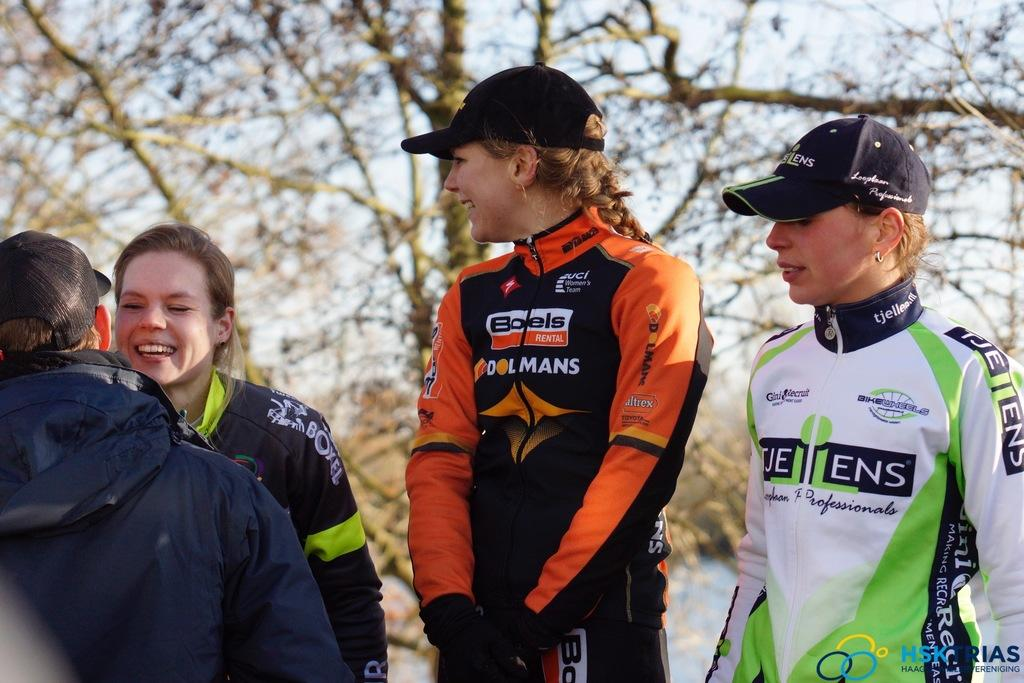What is happening in the image? There is a group of people in the image, and they are standing. How are the people in the image feeling? The people in the image are smiling. Can you describe any accessories the people are wearing? Some of the people are wearing caps. What can be seen in the background of the image? There are trees and the sky visible in the background of the image. What type of van is parked next to the group of people in the image? There is no van present in the image; it only features a group of people standing and smiling. 